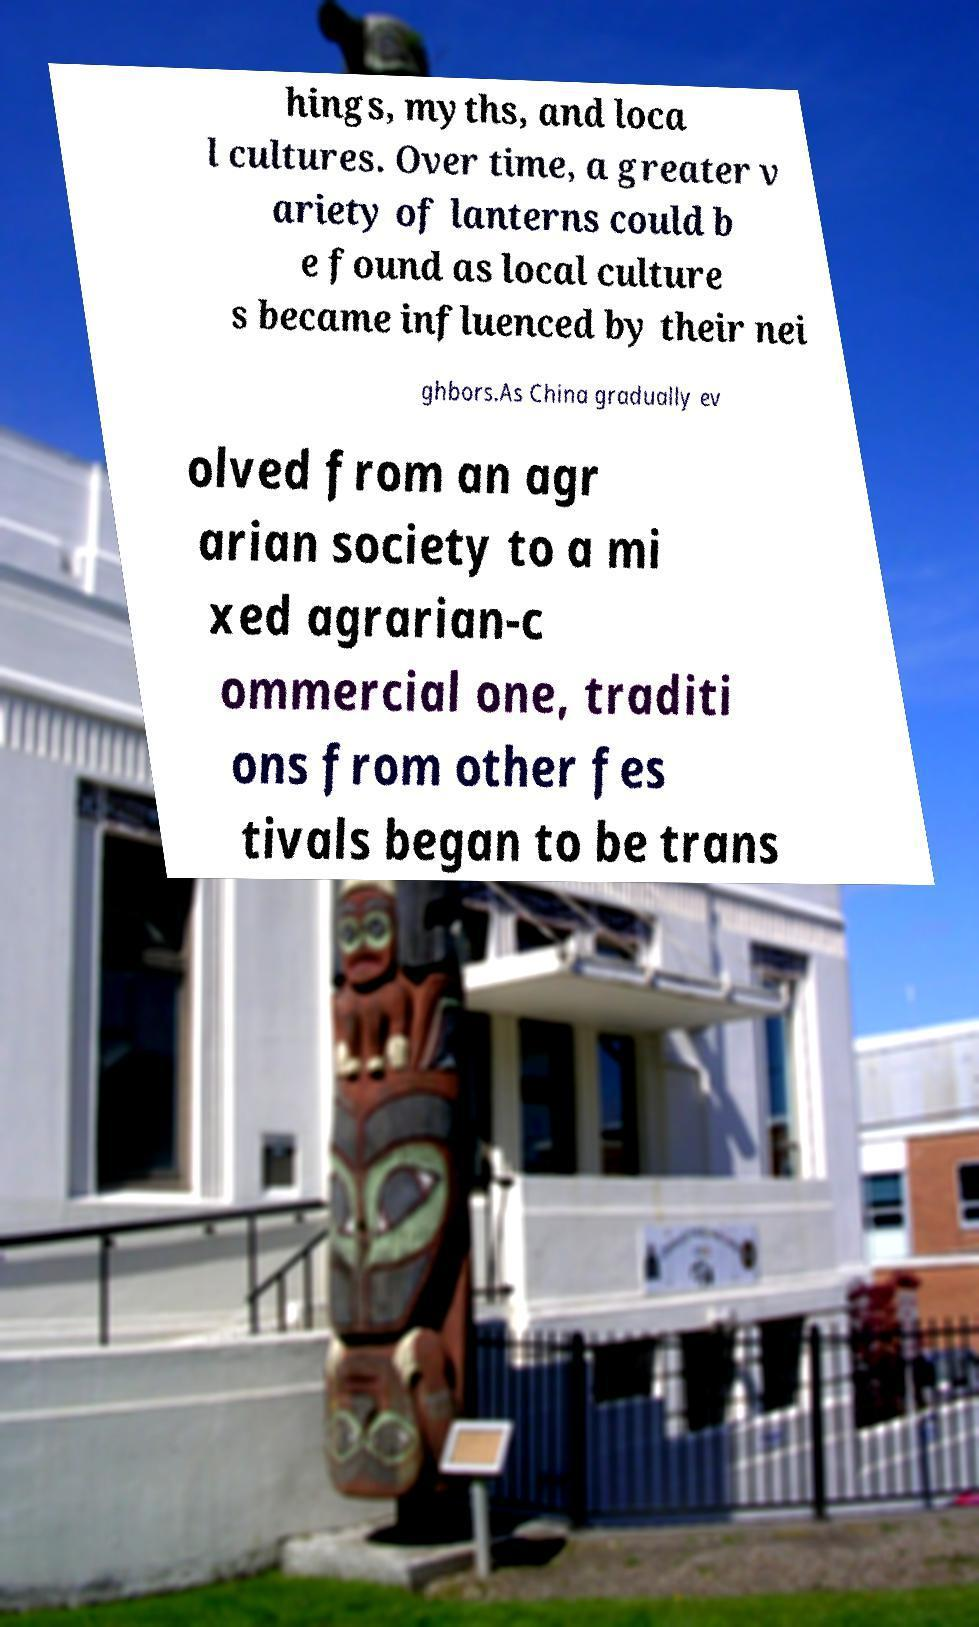Please identify and transcribe the text found in this image. hings, myths, and loca l cultures. Over time, a greater v ariety of lanterns could b e found as local culture s became influenced by their nei ghbors.As China gradually ev olved from an agr arian society to a mi xed agrarian-c ommercial one, traditi ons from other fes tivals began to be trans 